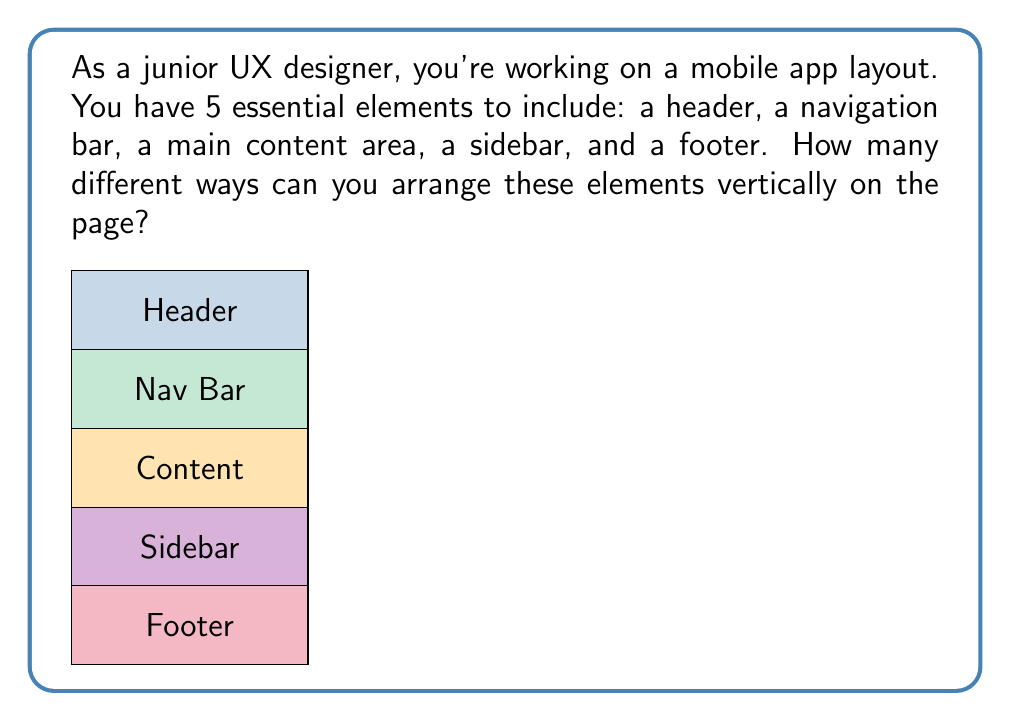Give your solution to this math problem. Let's approach this step-by-step:

1) This problem is essentially asking for the number of permutations of 5 distinct elements.

2) In permutations, the order matters, and we're using all elements.

3) The formula for permutations of n distinct objects is:

   $$P(n) = n!$$

   Where $n!$ represents the factorial of $n$.

4) In this case, $n = 5$ (for the 5 page elements).

5) So, we need to calculate:

   $$P(5) = 5!$$

6) Let's expand this:

   $$5! = 5 \times 4 \times 3 \times 2 \times 1 = 120$$

Therefore, there are 120 different ways to arrange these 5 elements vertically on the page.

This demonstrates the importance of carefully considering layout options in UX design, as there are many possible arrangements even with just a few elements.
Answer: $120$ 